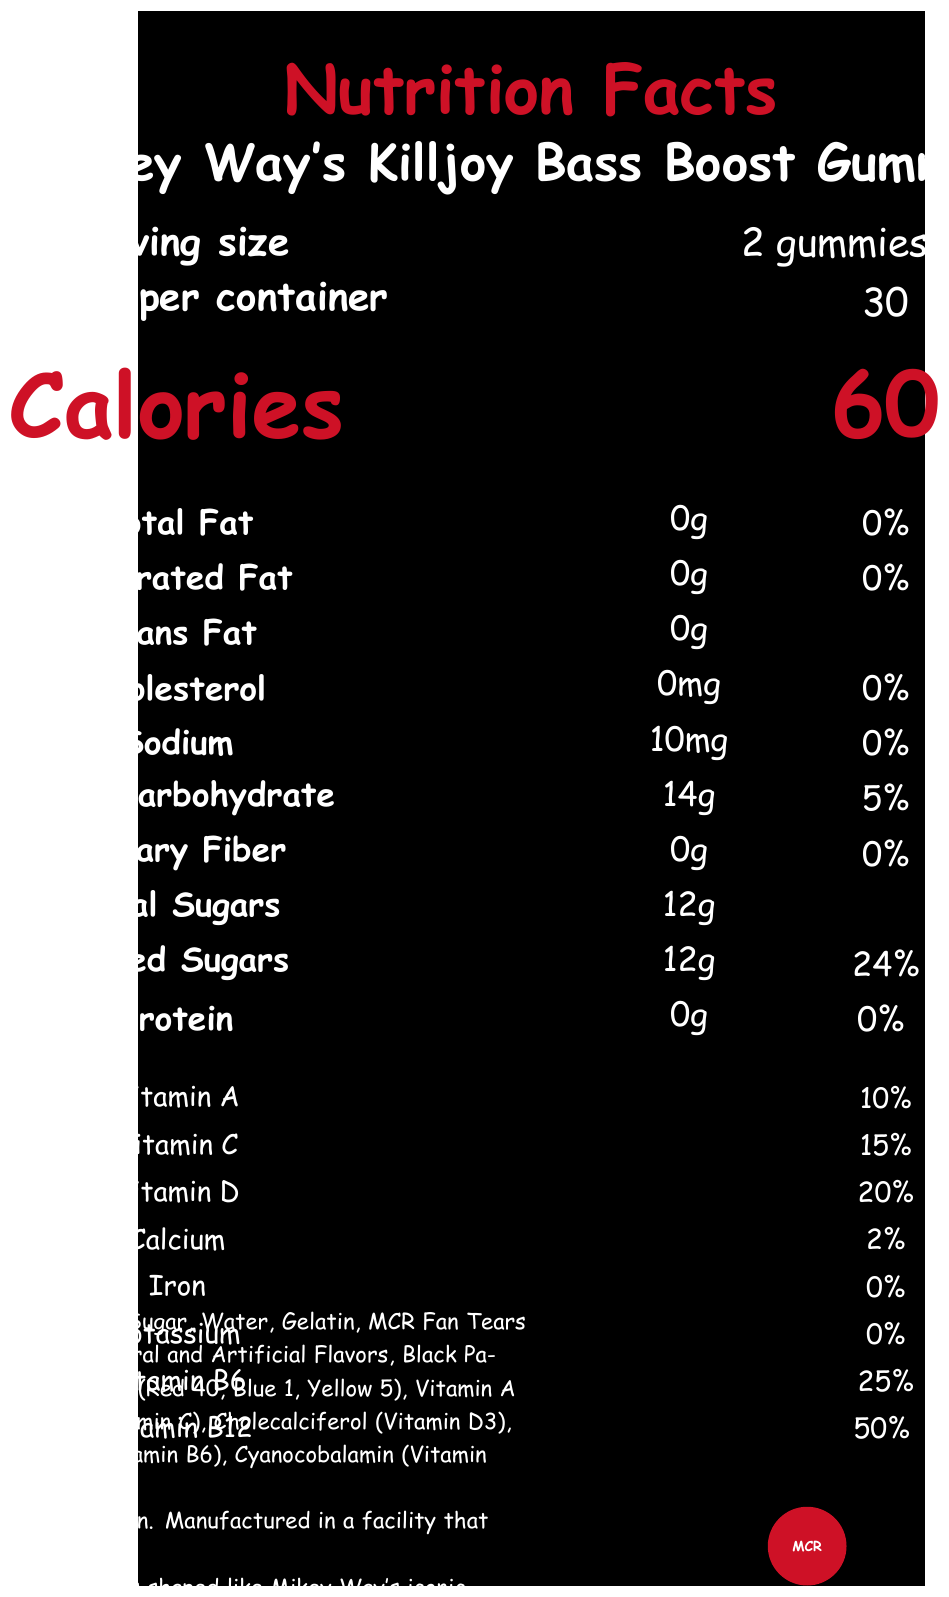what is the serving size? The serving size is indicated as "2 gummies (15g)" under the "Serving size" section of the document.
Answer: 2 gummies (15g) how many servings are there per container? The "Servings per container" section specifies that there are 30 servings per container.
Answer: 30 how many calories are in one serving? The "Calories" section shows that there are 60 calories per serving.
Answer: 60 List the vitamins included in the gummies and their percentages. The document lists the percentage daily values of these vitamins under the "Vitamins" section.
Answer: Vitamin A (10%), Vitamin C (15%), Vitamin D (20%), Vitamin B6 (25%), Vitamin B12 (50%) what is the total carbohydrate content for one serving? The "Total Carbohydrate" content specified under the "Main nutrients" section is 14g.
Answer: 14g which ingredient is added for the flavor that might appeal to MCR fans? The "Ingredients" section lists "MCR Fan Tears (for flavor)" among the ingredients.
Answer: MCR Fan Tears What percentage of daily value does the added sugars in one serving contribute? The "Added Sugars" shows a 24% daily value in the main nutrients section.
Answer: 24% how much sodium is in one serving? The sodium content is listed as 10mg under the "Main nutrients" section.
Answer: 10mg which of the following vitamins has the highest percentage of daily value? A. Vitamin A B. Vitamin C C. Vitamin D D. Vitamin B12 Under the "Vitamins" section, Vitamin B12 has the highest percentage of daily value at 50%.
Answer: D. Vitamin B12 which ingredient is used both as a flavor and for MCR fan appeal? A. Glucose Syrup B. MCR Fan Tears C. Black Parade Confetti Extract D. Citric Acid The document states in the "Ingredients" section that MCR Fan Tears are used "for flavor."
Answer: B. MCR Fan Tears are the gummies suitable for individuals with a nut allergy? The allergen info states: "Contains gelatin. Manufactured in a facility that processes soy and tree nuts."
Answer: No Summarize the main idea of the document. The document provides detailed nutrition facts, ingredients, and supplementary information about Mikey Way's Killjoy Bass Boost Gummies, a limited-edition product shaped like a bass guitar and featuring several MCR-themed elements.
Answer: Mikey Way's Killjoy Bass Boost Gummies are vitamin supplements shaped like Mikey Way’s iconic Fender Precision Bass guitar. Each serving of 2 gummies (15g) contains 60 calories and provides various vitamins like Vitamin A, C, D, B6, and B12. The product contains ingredients like glucose syrup, MCR Fan Tears, and Black Parade Confetti Extract. It is manufactured by Revenge Records Supplements, LLC, and includes a random MCR guitar pick in each bottle as part of a collector's edition. Does the document state the manufacturing date of the gummies? The document doesn't contain any information regarding the manufacturing date.
Answer: Cannot be determined who is the manufacturer of the gummies? The manufacturer is provided in the footer of the document as Revenge Records Supplements, LLC.
Answer: Revenge Records Supplements, LLC what unique shape is each gummy designed to resemble? The "MCR Fun Fact" section mentions that each gummy is shaped like Mikey Way’s iconic Fender Precision Bass guitar.
Answer: Mikey Way’s iconic Fender Precision Bass guitar what special feature is included in the Collector's Edition? The "limited_edition_info" section states that the Collector's Edition includes one random MCR guitar pick in every bottle.
Answer: One random MCR guitar pick in every bottle what is the purpose of the disclaimers listed at the bottom of the document? The disclaimer clarifies that statements have not been evaluated by the FDA and that the product is not intended for medical purposes.
Answer: Inform consumers that the product is not intended to diagnose, treat, cure, or prevent any disease 